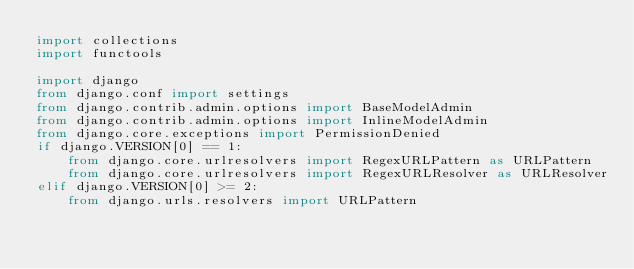Convert code to text. <code><loc_0><loc_0><loc_500><loc_500><_Python_>import collections
import functools

import django
from django.conf import settings
from django.contrib.admin.options import BaseModelAdmin
from django.contrib.admin.options import InlineModelAdmin
from django.core.exceptions import PermissionDenied
if django.VERSION[0] == 1:
    from django.core.urlresolvers import RegexURLPattern as URLPattern
    from django.core.urlresolvers import RegexURLResolver as URLResolver
elif django.VERSION[0] >= 2:
    from django.urls.resolvers import URLPattern</code> 